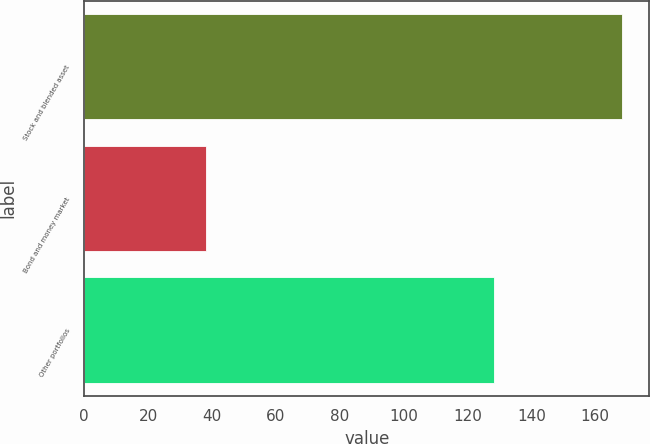Convert chart. <chart><loc_0><loc_0><loc_500><loc_500><bar_chart><fcel>Stock and blended asset<fcel>Bond and money market<fcel>Other portfolios<nl><fcel>168.5<fcel>38<fcel>128.2<nl></chart> 